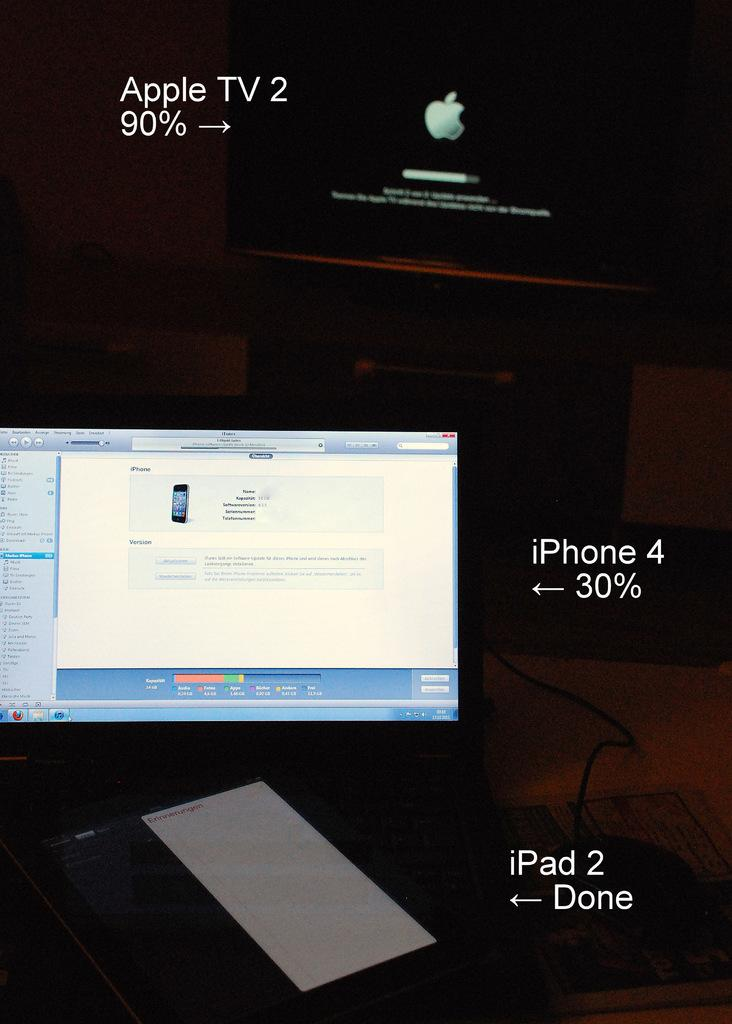<image>
Present a compact description of the photo's key features. A screen open near an Apple TV and an iPad 2. 